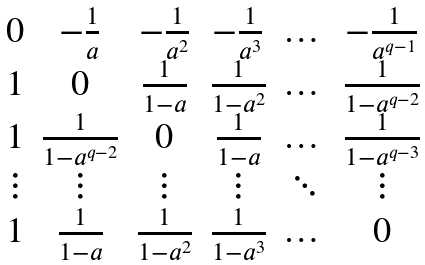<formula> <loc_0><loc_0><loc_500><loc_500>\begin{matrix} 0 & - \frac { 1 } { a } & - \frac { 1 } { a ^ { 2 } } & - \frac { 1 } { a ^ { 3 } } & \dots & - \frac { 1 } { a ^ { q - 1 } } \\ 1 & 0 & \frac { 1 } { 1 - a } & \frac { 1 } { 1 - a ^ { 2 } } & \dots & \frac { 1 } { 1 - a ^ { q - 2 } } \\ 1 & \frac { 1 } { 1 - a ^ { q - 2 } } & 0 & \frac { 1 } { 1 - a } & \dots & \frac { 1 } { 1 - a ^ { q - 3 } } \\ \vdots & \vdots & \vdots & \vdots & \ddots & \vdots \\ 1 & \frac { 1 } { 1 - a } & \frac { 1 } { 1 - a ^ { 2 } } & \frac { 1 } { 1 - a ^ { 3 } } & \dots & 0 \end{matrix}</formula> 